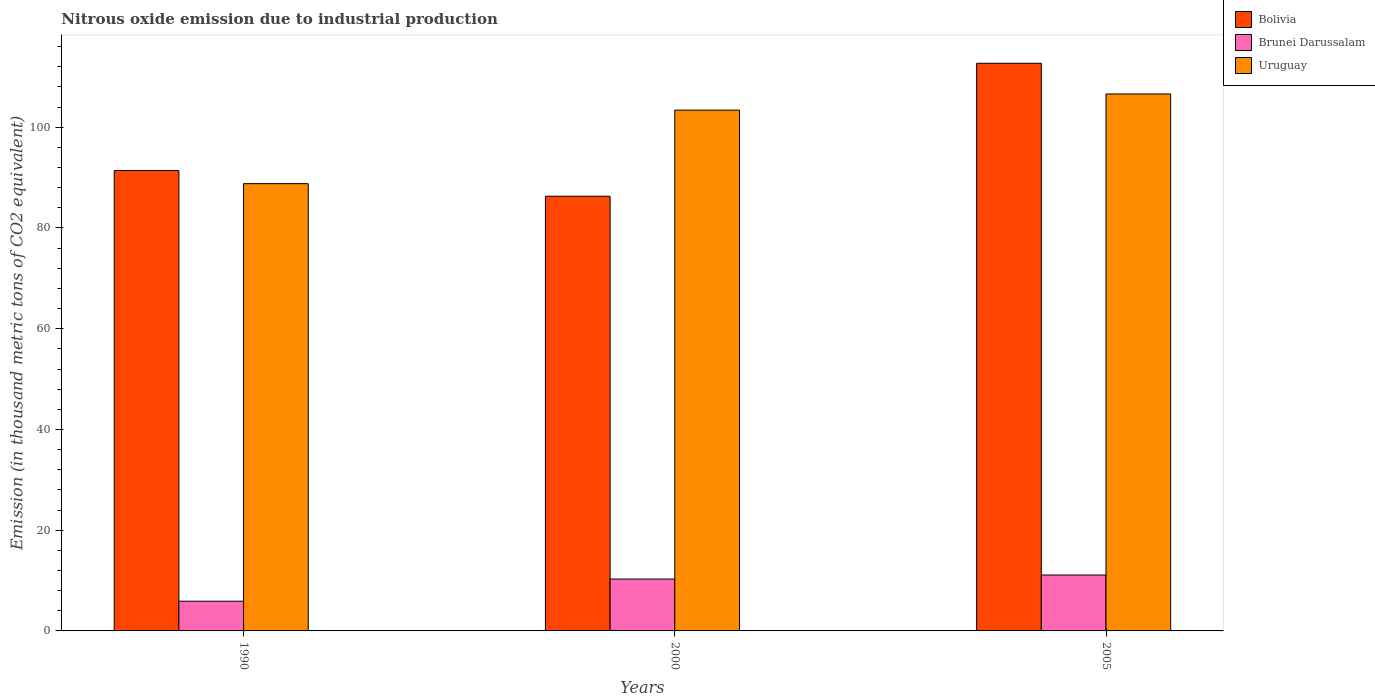How many groups of bars are there?
Your response must be concise. 3. Are the number of bars per tick equal to the number of legend labels?
Ensure brevity in your answer.  Yes. Are the number of bars on each tick of the X-axis equal?
Ensure brevity in your answer.  Yes. How many bars are there on the 2nd tick from the left?
Your answer should be compact. 3. What is the label of the 2nd group of bars from the left?
Provide a succinct answer. 2000. What is the amount of nitrous oxide emitted in Bolivia in 1990?
Your answer should be compact. 91.4. Across all years, what is the minimum amount of nitrous oxide emitted in Brunei Darussalam?
Make the answer very short. 5.9. In which year was the amount of nitrous oxide emitted in Uruguay minimum?
Offer a terse response. 1990. What is the total amount of nitrous oxide emitted in Bolivia in the graph?
Offer a very short reply. 290.4. What is the difference between the amount of nitrous oxide emitted in Brunei Darussalam in 1990 and that in 2005?
Your response must be concise. -5.2. What is the difference between the amount of nitrous oxide emitted in Brunei Darussalam in 2005 and the amount of nitrous oxide emitted in Uruguay in 1990?
Provide a short and direct response. -77.7. What is the average amount of nitrous oxide emitted in Brunei Darussalam per year?
Offer a very short reply. 9.1. In the year 1990, what is the difference between the amount of nitrous oxide emitted in Bolivia and amount of nitrous oxide emitted in Uruguay?
Your response must be concise. 2.6. What is the ratio of the amount of nitrous oxide emitted in Bolivia in 2000 to that in 2005?
Offer a very short reply. 0.77. Is the amount of nitrous oxide emitted in Uruguay in 1990 less than that in 2000?
Offer a terse response. Yes. What is the difference between the highest and the second highest amount of nitrous oxide emitted in Uruguay?
Keep it short and to the point. 3.2. What is the difference between the highest and the lowest amount of nitrous oxide emitted in Uruguay?
Offer a very short reply. 17.8. What does the 1st bar from the right in 2000 represents?
Offer a terse response. Uruguay. Is it the case that in every year, the sum of the amount of nitrous oxide emitted in Brunei Darussalam and amount of nitrous oxide emitted in Bolivia is greater than the amount of nitrous oxide emitted in Uruguay?
Provide a succinct answer. No. Are all the bars in the graph horizontal?
Offer a very short reply. No. Where does the legend appear in the graph?
Provide a short and direct response. Top right. How many legend labels are there?
Your answer should be compact. 3. How are the legend labels stacked?
Your answer should be compact. Vertical. What is the title of the graph?
Offer a terse response. Nitrous oxide emission due to industrial production. What is the label or title of the Y-axis?
Make the answer very short. Emission (in thousand metric tons of CO2 equivalent). What is the Emission (in thousand metric tons of CO2 equivalent) of Bolivia in 1990?
Offer a terse response. 91.4. What is the Emission (in thousand metric tons of CO2 equivalent) in Brunei Darussalam in 1990?
Offer a very short reply. 5.9. What is the Emission (in thousand metric tons of CO2 equivalent) in Uruguay in 1990?
Your answer should be very brief. 88.8. What is the Emission (in thousand metric tons of CO2 equivalent) in Bolivia in 2000?
Give a very brief answer. 86.3. What is the Emission (in thousand metric tons of CO2 equivalent) of Brunei Darussalam in 2000?
Provide a short and direct response. 10.3. What is the Emission (in thousand metric tons of CO2 equivalent) of Uruguay in 2000?
Make the answer very short. 103.4. What is the Emission (in thousand metric tons of CO2 equivalent) of Bolivia in 2005?
Keep it short and to the point. 112.7. What is the Emission (in thousand metric tons of CO2 equivalent) in Uruguay in 2005?
Your answer should be compact. 106.6. Across all years, what is the maximum Emission (in thousand metric tons of CO2 equivalent) of Bolivia?
Keep it short and to the point. 112.7. Across all years, what is the maximum Emission (in thousand metric tons of CO2 equivalent) of Brunei Darussalam?
Your response must be concise. 11.1. Across all years, what is the maximum Emission (in thousand metric tons of CO2 equivalent) of Uruguay?
Provide a succinct answer. 106.6. Across all years, what is the minimum Emission (in thousand metric tons of CO2 equivalent) in Bolivia?
Your answer should be compact. 86.3. Across all years, what is the minimum Emission (in thousand metric tons of CO2 equivalent) of Uruguay?
Your answer should be very brief. 88.8. What is the total Emission (in thousand metric tons of CO2 equivalent) in Bolivia in the graph?
Your answer should be compact. 290.4. What is the total Emission (in thousand metric tons of CO2 equivalent) in Brunei Darussalam in the graph?
Your answer should be very brief. 27.3. What is the total Emission (in thousand metric tons of CO2 equivalent) in Uruguay in the graph?
Your answer should be very brief. 298.8. What is the difference between the Emission (in thousand metric tons of CO2 equivalent) in Bolivia in 1990 and that in 2000?
Offer a very short reply. 5.1. What is the difference between the Emission (in thousand metric tons of CO2 equivalent) in Brunei Darussalam in 1990 and that in 2000?
Provide a short and direct response. -4.4. What is the difference between the Emission (in thousand metric tons of CO2 equivalent) of Uruguay in 1990 and that in 2000?
Your response must be concise. -14.6. What is the difference between the Emission (in thousand metric tons of CO2 equivalent) of Bolivia in 1990 and that in 2005?
Give a very brief answer. -21.3. What is the difference between the Emission (in thousand metric tons of CO2 equivalent) in Uruguay in 1990 and that in 2005?
Your answer should be compact. -17.8. What is the difference between the Emission (in thousand metric tons of CO2 equivalent) of Bolivia in 2000 and that in 2005?
Offer a very short reply. -26.4. What is the difference between the Emission (in thousand metric tons of CO2 equivalent) of Uruguay in 2000 and that in 2005?
Offer a terse response. -3.2. What is the difference between the Emission (in thousand metric tons of CO2 equivalent) of Bolivia in 1990 and the Emission (in thousand metric tons of CO2 equivalent) of Brunei Darussalam in 2000?
Make the answer very short. 81.1. What is the difference between the Emission (in thousand metric tons of CO2 equivalent) in Brunei Darussalam in 1990 and the Emission (in thousand metric tons of CO2 equivalent) in Uruguay in 2000?
Your answer should be compact. -97.5. What is the difference between the Emission (in thousand metric tons of CO2 equivalent) of Bolivia in 1990 and the Emission (in thousand metric tons of CO2 equivalent) of Brunei Darussalam in 2005?
Your answer should be compact. 80.3. What is the difference between the Emission (in thousand metric tons of CO2 equivalent) in Bolivia in 1990 and the Emission (in thousand metric tons of CO2 equivalent) in Uruguay in 2005?
Provide a succinct answer. -15.2. What is the difference between the Emission (in thousand metric tons of CO2 equivalent) of Brunei Darussalam in 1990 and the Emission (in thousand metric tons of CO2 equivalent) of Uruguay in 2005?
Keep it short and to the point. -100.7. What is the difference between the Emission (in thousand metric tons of CO2 equivalent) in Bolivia in 2000 and the Emission (in thousand metric tons of CO2 equivalent) in Brunei Darussalam in 2005?
Ensure brevity in your answer.  75.2. What is the difference between the Emission (in thousand metric tons of CO2 equivalent) of Bolivia in 2000 and the Emission (in thousand metric tons of CO2 equivalent) of Uruguay in 2005?
Your answer should be compact. -20.3. What is the difference between the Emission (in thousand metric tons of CO2 equivalent) of Brunei Darussalam in 2000 and the Emission (in thousand metric tons of CO2 equivalent) of Uruguay in 2005?
Ensure brevity in your answer.  -96.3. What is the average Emission (in thousand metric tons of CO2 equivalent) of Bolivia per year?
Provide a succinct answer. 96.8. What is the average Emission (in thousand metric tons of CO2 equivalent) in Brunei Darussalam per year?
Offer a very short reply. 9.1. What is the average Emission (in thousand metric tons of CO2 equivalent) of Uruguay per year?
Ensure brevity in your answer.  99.6. In the year 1990, what is the difference between the Emission (in thousand metric tons of CO2 equivalent) of Bolivia and Emission (in thousand metric tons of CO2 equivalent) of Brunei Darussalam?
Your response must be concise. 85.5. In the year 1990, what is the difference between the Emission (in thousand metric tons of CO2 equivalent) in Brunei Darussalam and Emission (in thousand metric tons of CO2 equivalent) in Uruguay?
Make the answer very short. -82.9. In the year 2000, what is the difference between the Emission (in thousand metric tons of CO2 equivalent) of Bolivia and Emission (in thousand metric tons of CO2 equivalent) of Uruguay?
Give a very brief answer. -17.1. In the year 2000, what is the difference between the Emission (in thousand metric tons of CO2 equivalent) of Brunei Darussalam and Emission (in thousand metric tons of CO2 equivalent) of Uruguay?
Provide a short and direct response. -93.1. In the year 2005, what is the difference between the Emission (in thousand metric tons of CO2 equivalent) of Bolivia and Emission (in thousand metric tons of CO2 equivalent) of Brunei Darussalam?
Provide a succinct answer. 101.6. In the year 2005, what is the difference between the Emission (in thousand metric tons of CO2 equivalent) of Brunei Darussalam and Emission (in thousand metric tons of CO2 equivalent) of Uruguay?
Give a very brief answer. -95.5. What is the ratio of the Emission (in thousand metric tons of CO2 equivalent) in Bolivia in 1990 to that in 2000?
Make the answer very short. 1.06. What is the ratio of the Emission (in thousand metric tons of CO2 equivalent) of Brunei Darussalam in 1990 to that in 2000?
Offer a very short reply. 0.57. What is the ratio of the Emission (in thousand metric tons of CO2 equivalent) of Uruguay in 1990 to that in 2000?
Offer a terse response. 0.86. What is the ratio of the Emission (in thousand metric tons of CO2 equivalent) in Bolivia in 1990 to that in 2005?
Offer a very short reply. 0.81. What is the ratio of the Emission (in thousand metric tons of CO2 equivalent) of Brunei Darussalam in 1990 to that in 2005?
Give a very brief answer. 0.53. What is the ratio of the Emission (in thousand metric tons of CO2 equivalent) in Uruguay in 1990 to that in 2005?
Give a very brief answer. 0.83. What is the ratio of the Emission (in thousand metric tons of CO2 equivalent) in Bolivia in 2000 to that in 2005?
Ensure brevity in your answer.  0.77. What is the ratio of the Emission (in thousand metric tons of CO2 equivalent) of Brunei Darussalam in 2000 to that in 2005?
Offer a very short reply. 0.93. What is the difference between the highest and the second highest Emission (in thousand metric tons of CO2 equivalent) in Bolivia?
Your answer should be compact. 21.3. What is the difference between the highest and the lowest Emission (in thousand metric tons of CO2 equivalent) in Bolivia?
Make the answer very short. 26.4. What is the difference between the highest and the lowest Emission (in thousand metric tons of CO2 equivalent) in Uruguay?
Provide a succinct answer. 17.8. 